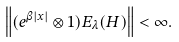<formula> <loc_0><loc_0><loc_500><loc_500>\left \| ( e ^ { \beta | x | } \otimes 1 ) E _ { \lambda } ( H ) \right \| < \infty .</formula> 